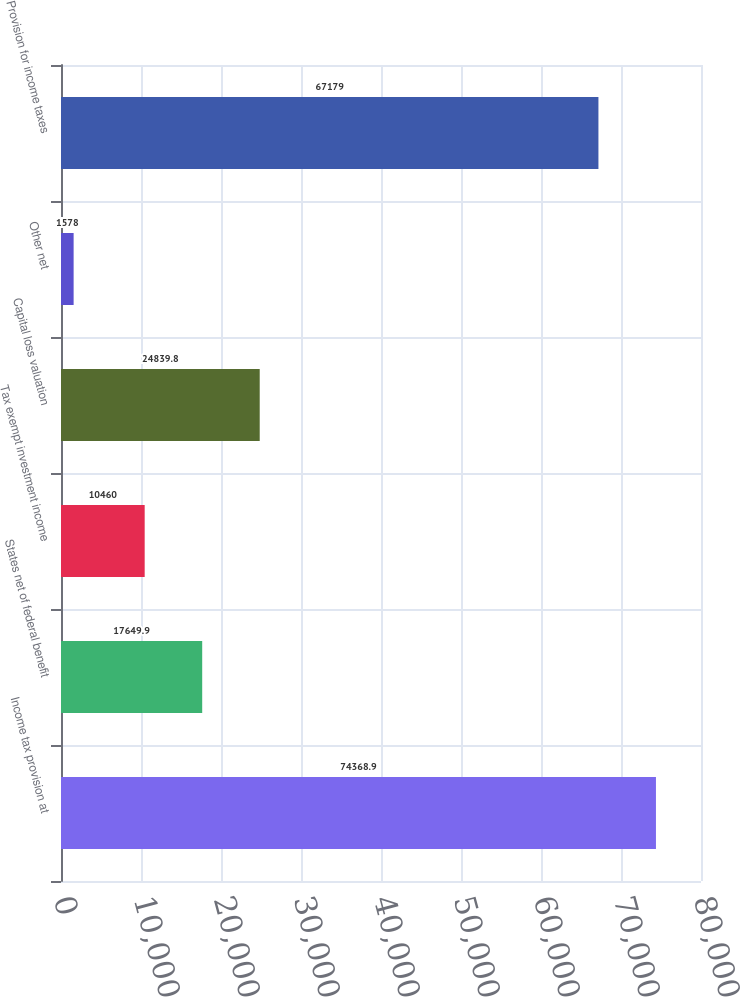Convert chart to OTSL. <chart><loc_0><loc_0><loc_500><loc_500><bar_chart><fcel>Income tax provision at<fcel>States net of federal benefit<fcel>Tax exempt investment income<fcel>Capital loss valuation<fcel>Other net<fcel>Provision for income taxes<nl><fcel>74368.9<fcel>17649.9<fcel>10460<fcel>24839.8<fcel>1578<fcel>67179<nl></chart> 